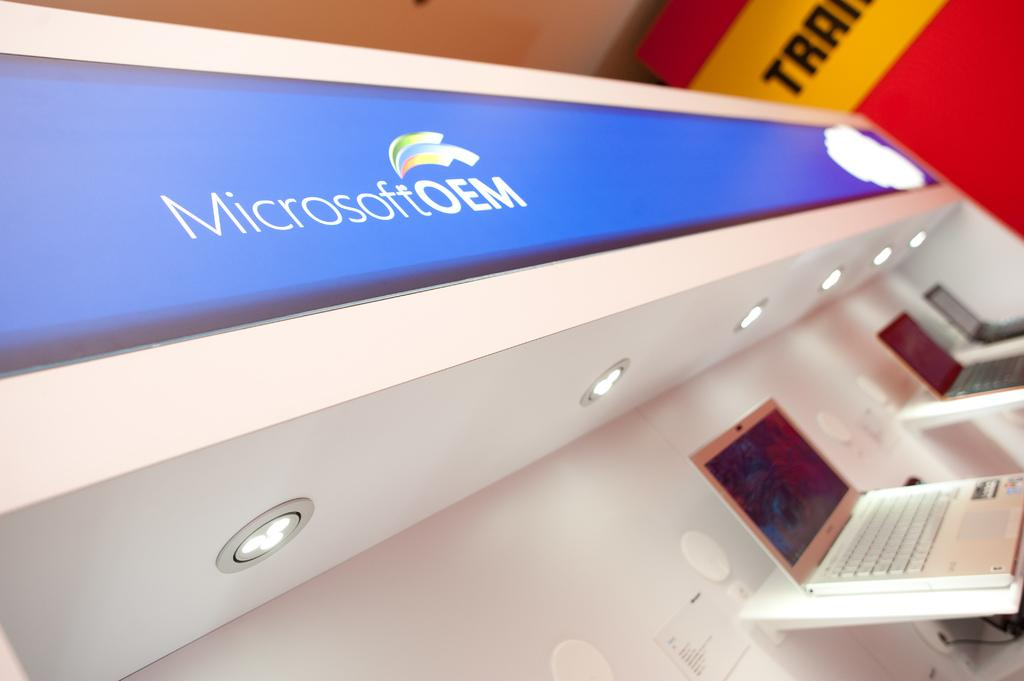<image>
Provide a brief description of the given image. the name Microsoft is on the area above the lights 